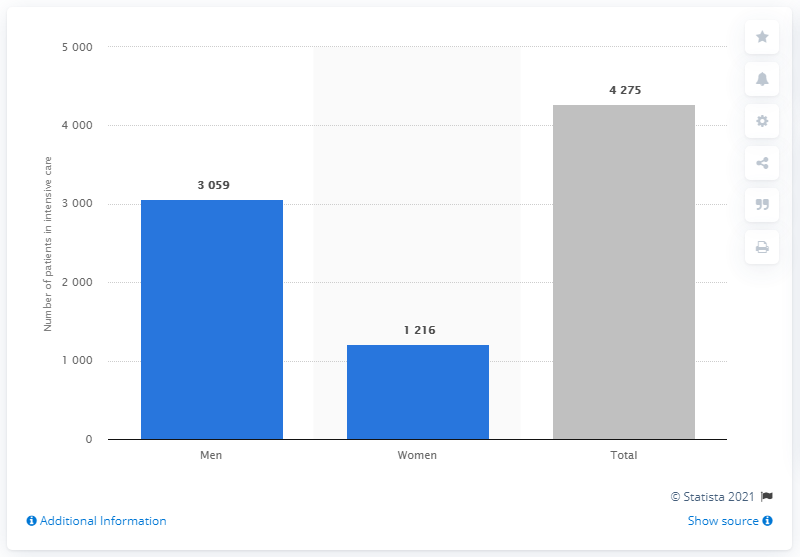Give some essential details in this illustration. As of the latest data available, a total of 4,275 COVID-19 patients have been admitted to intensive care in Sweden. There are more male COVID-19 patients in intensive care in Sweden than there are female patients. 